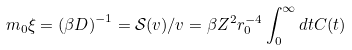Convert formula to latex. <formula><loc_0><loc_0><loc_500><loc_500>m _ { 0 } \xi = \left ( \beta D \right ) ^ { - 1 } = \mathcal { S } ( v ) / v = \beta Z ^ { 2 } r _ { 0 } ^ { - 4 } \int _ { 0 } ^ { \infty } d t C ( t )</formula> 